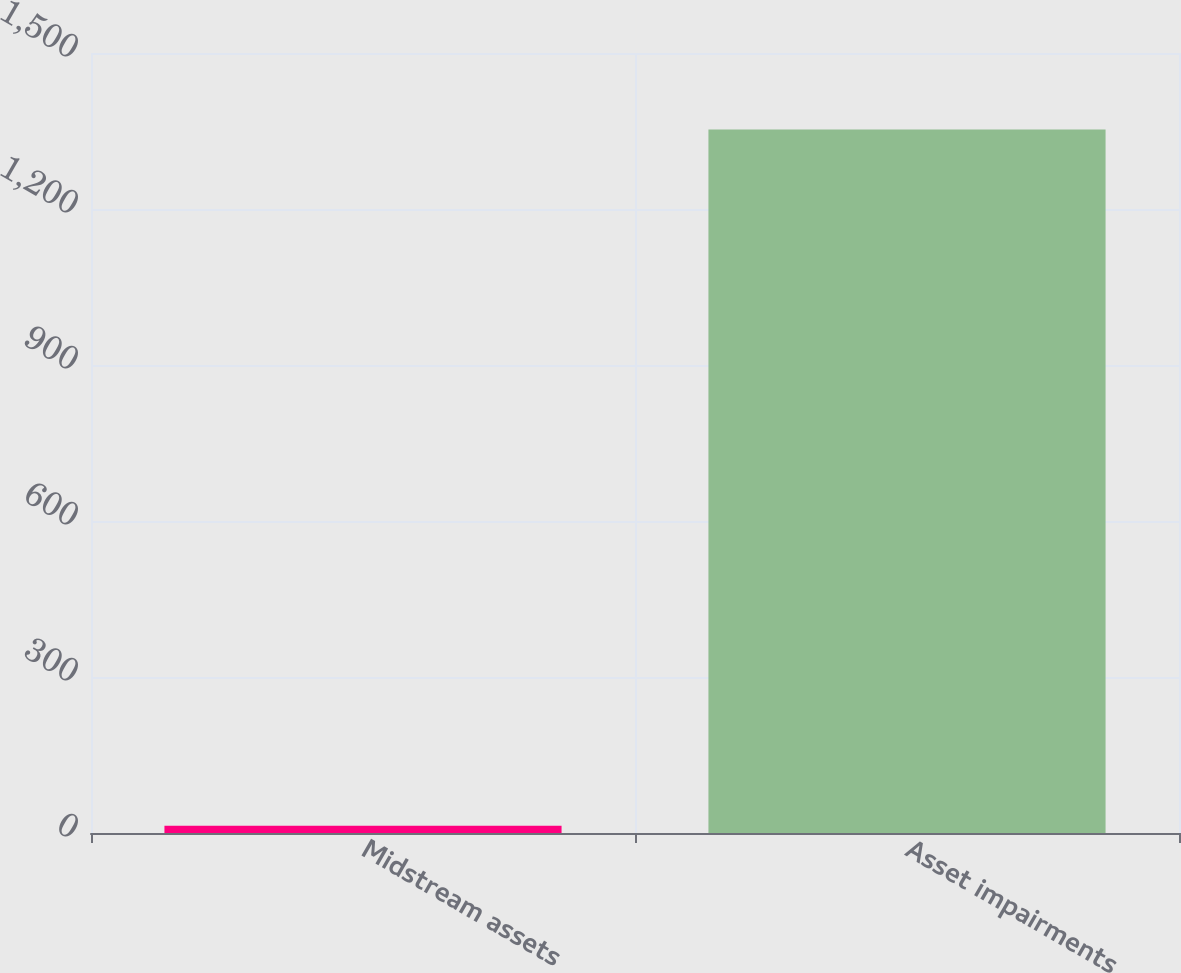<chart> <loc_0><loc_0><loc_500><loc_500><bar_chart><fcel>Midstream assets<fcel>Asset impairments<nl><fcel>14<fcel>1353<nl></chart> 